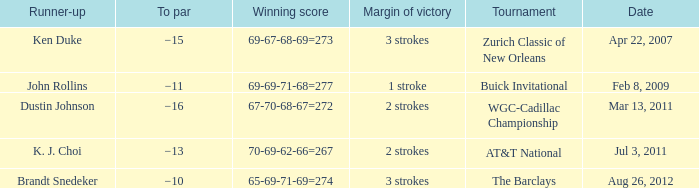Can you give me this table as a dict? {'header': ['Runner-up', 'To par', 'Winning score', 'Margin of victory', 'Tournament', 'Date'], 'rows': [['Ken Duke', '−15', '69-67-68-69=273', '3 strokes', 'Zurich Classic of New Orleans', 'Apr 22, 2007'], ['John Rollins', '−11', '69-69-71-68=277', '1 stroke', 'Buick Invitational', 'Feb 8, 2009'], ['Dustin Johnson', '−16', '67-70-68-67=272', '2 strokes', 'WGC-Cadillac Championship', 'Mar 13, 2011'], ['K. J. Choi', '−13', '70-69-62-66=267', '2 strokes', 'AT&T National', 'Jul 3, 2011'], ['Brandt Snedeker', '−10', '65-69-71-69=274', '3 strokes', 'The Barclays', 'Aug 26, 2012']]} Who was the runner-up in the tournament that has a margin of victory of 2 strokes, and a To par of −16? Dustin Johnson. 